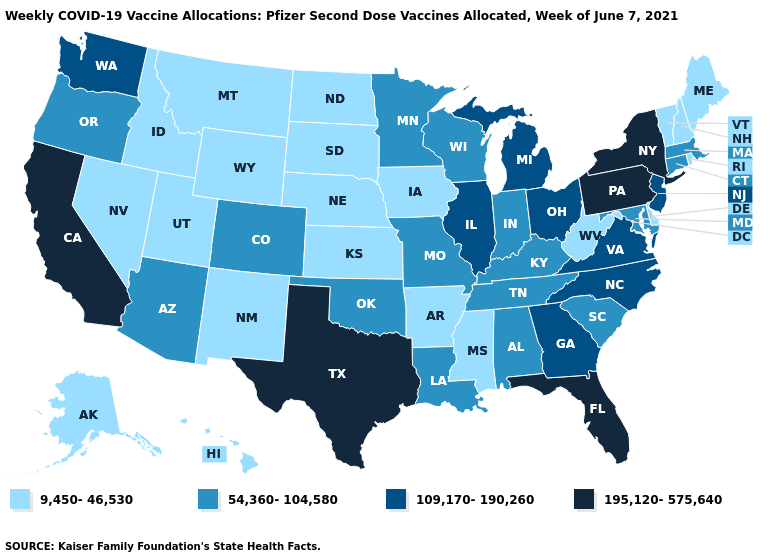What is the value of Kansas?
Answer briefly. 9,450-46,530. What is the lowest value in the USA?
Concise answer only. 9,450-46,530. Does Vermont have a lower value than North Dakota?
Keep it brief. No. Name the states that have a value in the range 54,360-104,580?
Be succinct. Alabama, Arizona, Colorado, Connecticut, Indiana, Kentucky, Louisiana, Maryland, Massachusetts, Minnesota, Missouri, Oklahoma, Oregon, South Carolina, Tennessee, Wisconsin. Among the states that border Indiana , does Kentucky have the highest value?
Short answer required. No. Among the states that border New Mexico , which have the lowest value?
Be succinct. Utah. Does Texas have the highest value in the USA?
Keep it brief. Yes. Does the first symbol in the legend represent the smallest category?
Concise answer only. Yes. Does Connecticut have a higher value than Maryland?
Write a very short answer. No. What is the value of Washington?
Quick response, please. 109,170-190,260. What is the value of Colorado?
Give a very brief answer. 54,360-104,580. Does the first symbol in the legend represent the smallest category?
Give a very brief answer. Yes. Does Texas have the same value as Florida?
Write a very short answer. Yes. Name the states that have a value in the range 9,450-46,530?
Be succinct. Alaska, Arkansas, Delaware, Hawaii, Idaho, Iowa, Kansas, Maine, Mississippi, Montana, Nebraska, Nevada, New Hampshire, New Mexico, North Dakota, Rhode Island, South Dakota, Utah, Vermont, West Virginia, Wyoming. Name the states that have a value in the range 9,450-46,530?
Short answer required. Alaska, Arkansas, Delaware, Hawaii, Idaho, Iowa, Kansas, Maine, Mississippi, Montana, Nebraska, Nevada, New Hampshire, New Mexico, North Dakota, Rhode Island, South Dakota, Utah, Vermont, West Virginia, Wyoming. 